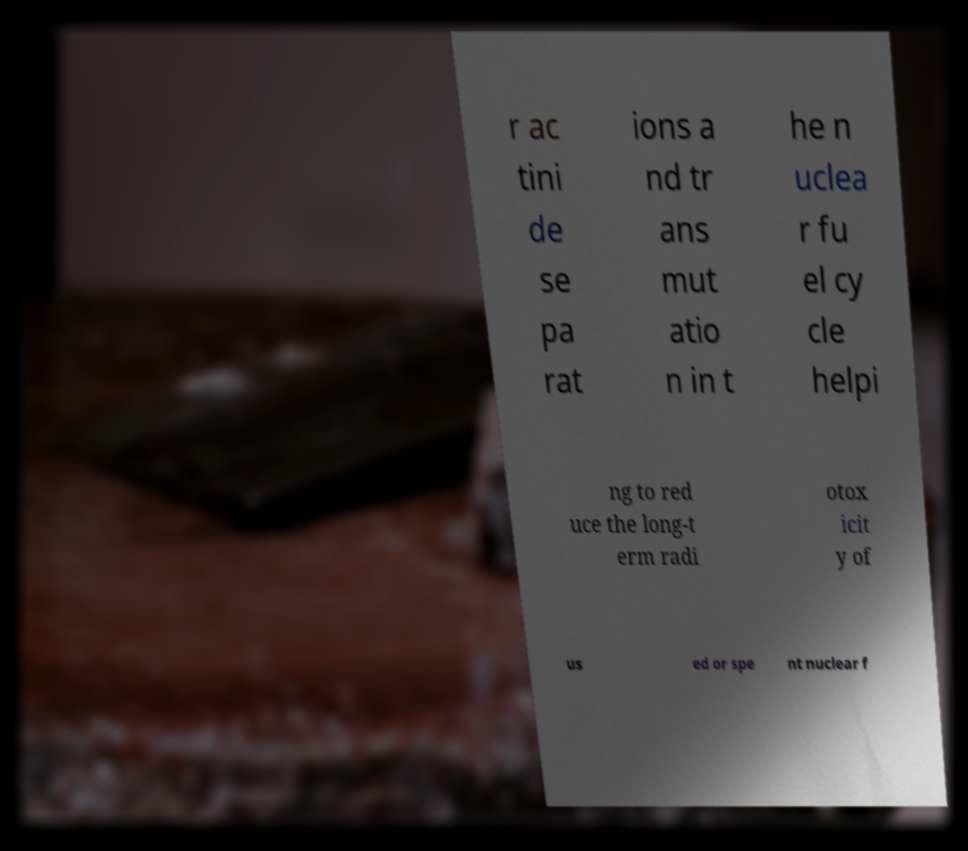Can you read and provide the text displayed in the image?This photo seems to have some interesting text. Can you extract and type it out for me? r ac tini de se pa rat ions a nd tr ans mut atio n in t he n uclea r fu el cy cle helpi ng to red uce the long-t erm radi otox icit y of us ed or spe nt nuclear f 